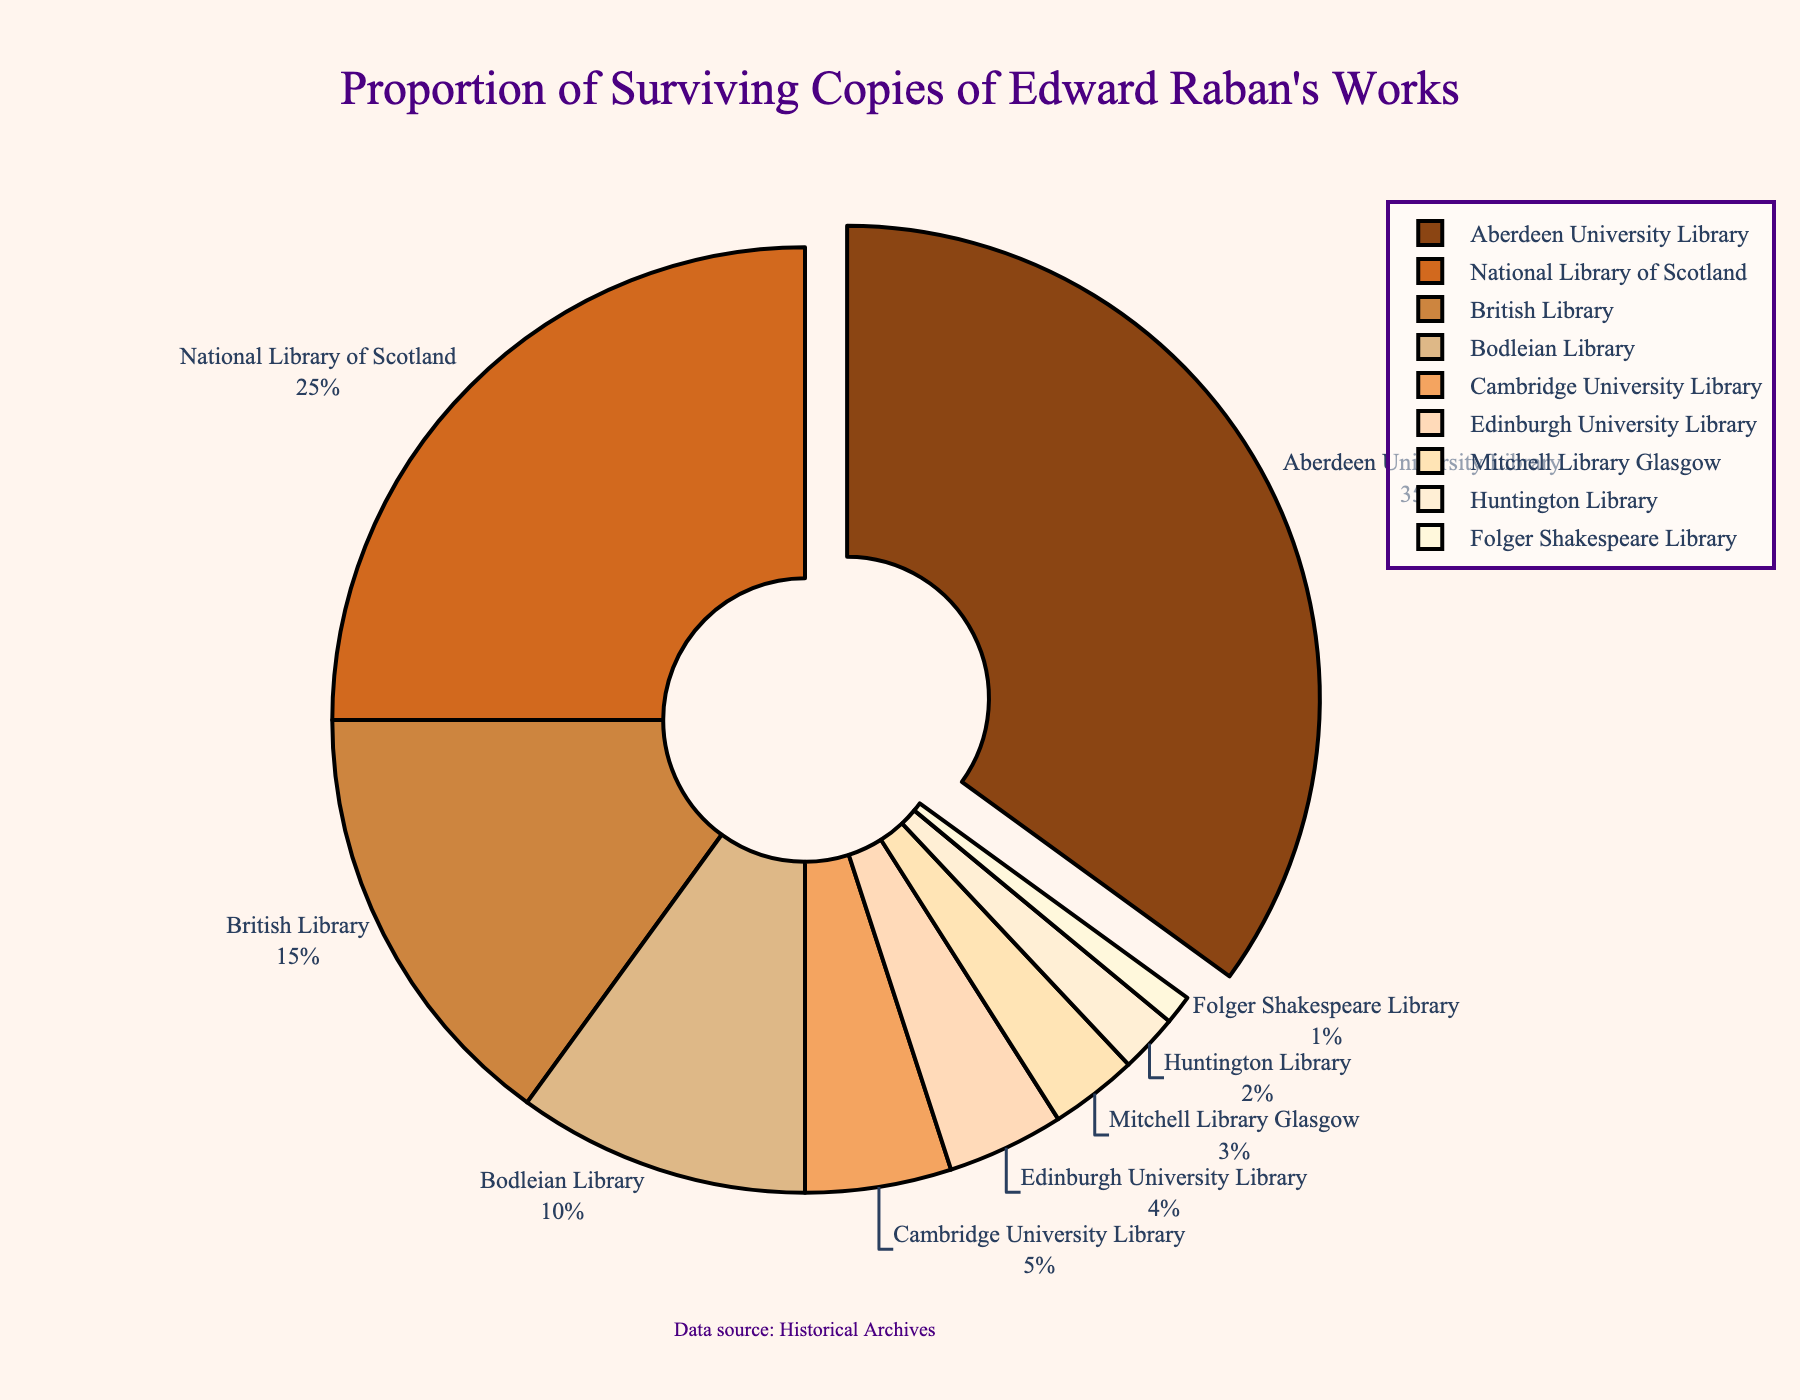Which library/collection has the highest proportion of surviving copies of Edward Raban's works? The pie chart highlights Aberdeen University Library by pulling the slice out, which indicates it has the highest proportion of surviving works. The label next to it shows 35%.
Answer: Aberdeen University Library What is the total percentage of surviving copies found in the National Library of Scotland and the British Library? Add the percentages for the National Library of Scotland (25%) and the British Library (15%): 25% + 15% = 40%.
Answer: 40% Which two libraries/collections have the smallest proportion of surviving copies? The smallest portions of the pie chart are the Folger Shakespeare Library (1%) and the Huntington Library (2%).
Answer: Folger Shakespeare Library and Huntington Library How much larger is the proportion of surviving copies in Aberdeen University Library compared to Edinburgh University Library? Subtract the percentage of Edinburgh University Library (4%) from Aberdeen University Library (35%): 35% - 4% = 31%.
Answer: 31% What is the combined proportion of surviving copies in Cambridge University Library, Edinburgh University Library, and the Folger Shakespeare Library? Add the percentages for Cambridge University Library (5%), Edinburgh University Library (4%), and the Folger Shakespeare Library (1%): 5% + 4% + 1% = 10%.
Answer: 10% Which collection has a higher proportion of surviving copies: Bodleian Library or Mitchell Library Glasgow? Compare the proportions: Bodleian Library (10%) vs Mitchell Library Glasgow (3%). The Bodleian Library has a higher percentage.
Answer: Bodleian Library What is the difference in the proportion of surviving copies between the Huntington Library and Mitchell Library Glasgow? Subtract the percentage of the Huntington Library (2%) from Mitchell Library Glasgow (3%): 3% - 2% = 1%.
Answer: 1% How does the proportion of surviving copies in the National Library of Scotland compare to that in the Cambridge University Library? Compare the proportions: National Library of Scotland (25%) and Cambridge University Library (5%). The National Library of Scotland has a higher percentage.
Answer: National Library of Scotland What is the average percentage of surviving copies across all libraries/collections? Sum all percentages and divide by the number of libraries/collections: (35 + 25 + 15 + 10 + 5 + 4 + 3 + 2 + 1) / 9 = 100 / 9 ≈ 11.11%
Answer: ≈ 11.11% Which library/collection has the second-largest proportion after Aberdeen University Library? The pie chart shows the second-largest slice is the National Library of Scotland with 25%.
Answer: National Library of Scotland 